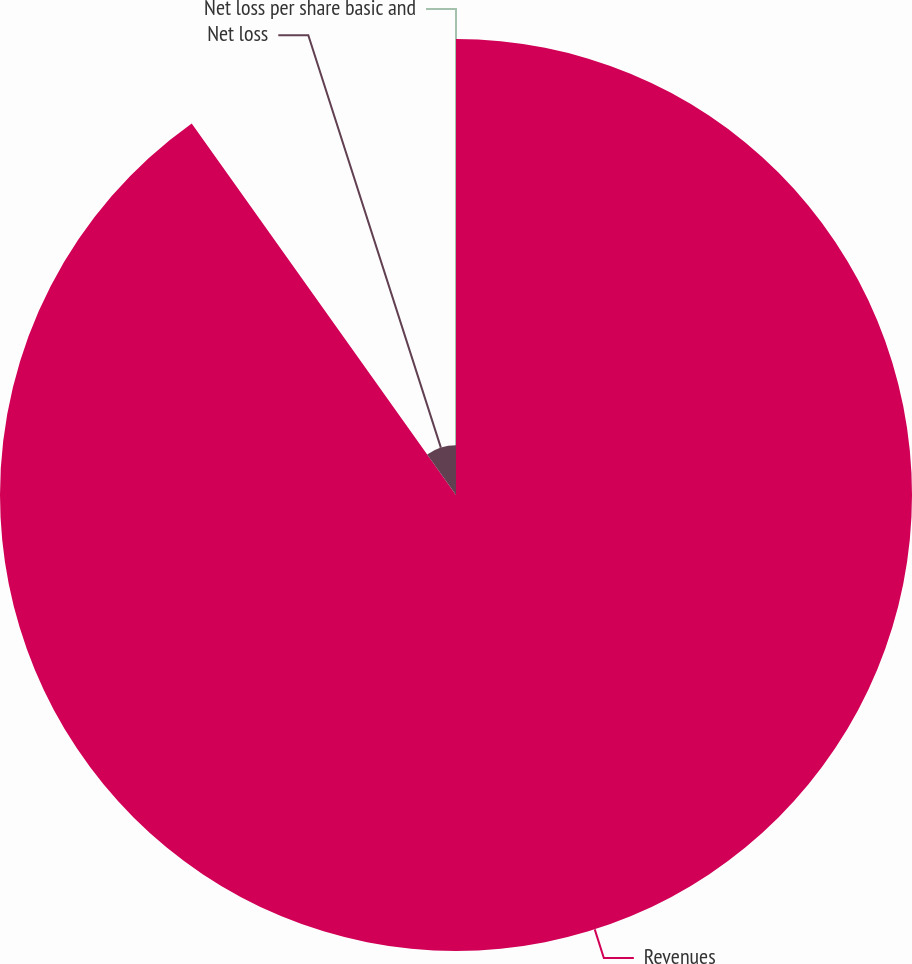Convert chart. <chart><loc_0><loc_0><loc_500><loc_500><pie_chart><fcel>Revenues<fcel>Net loss<fcel>Net loss per share basic and<nl><fcel>90.16%<fcel>9.84%<fcel>0.0%<nl></chart> 